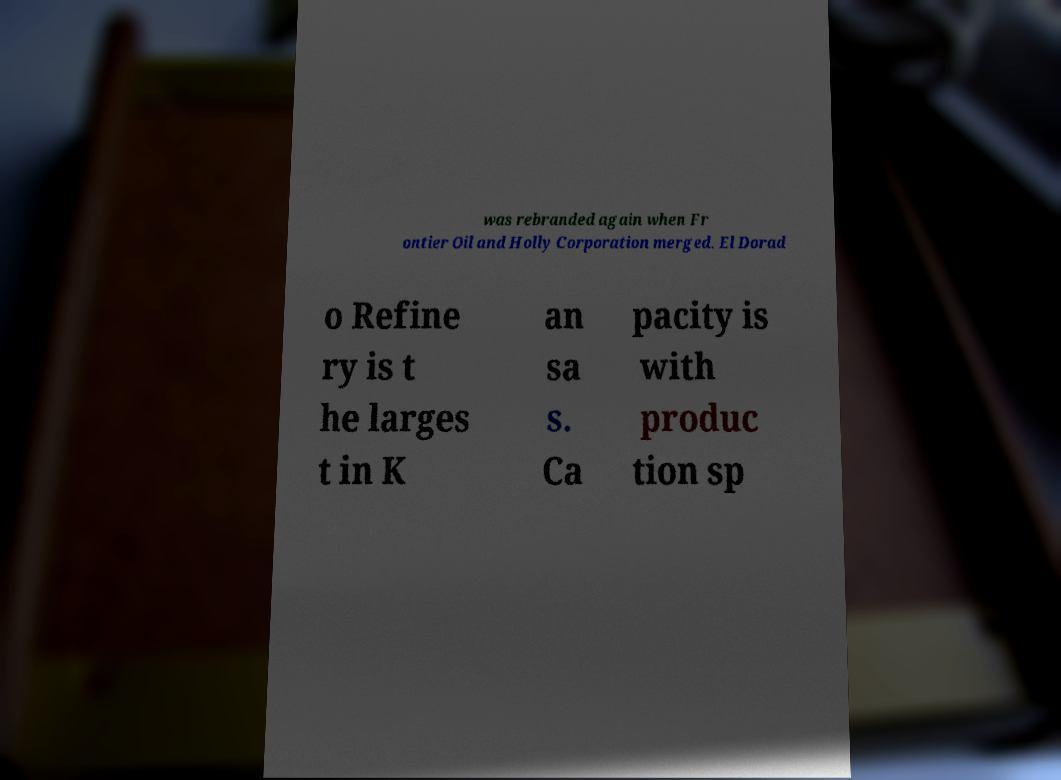Please read and relay the text visible in this image. What does it say? was rebranded again when Fr ontier Oil and Holly Corporation merged. El Dorad o Refine ry is t he larges t in K an sa s. Ca pacity is with produc tion sp 